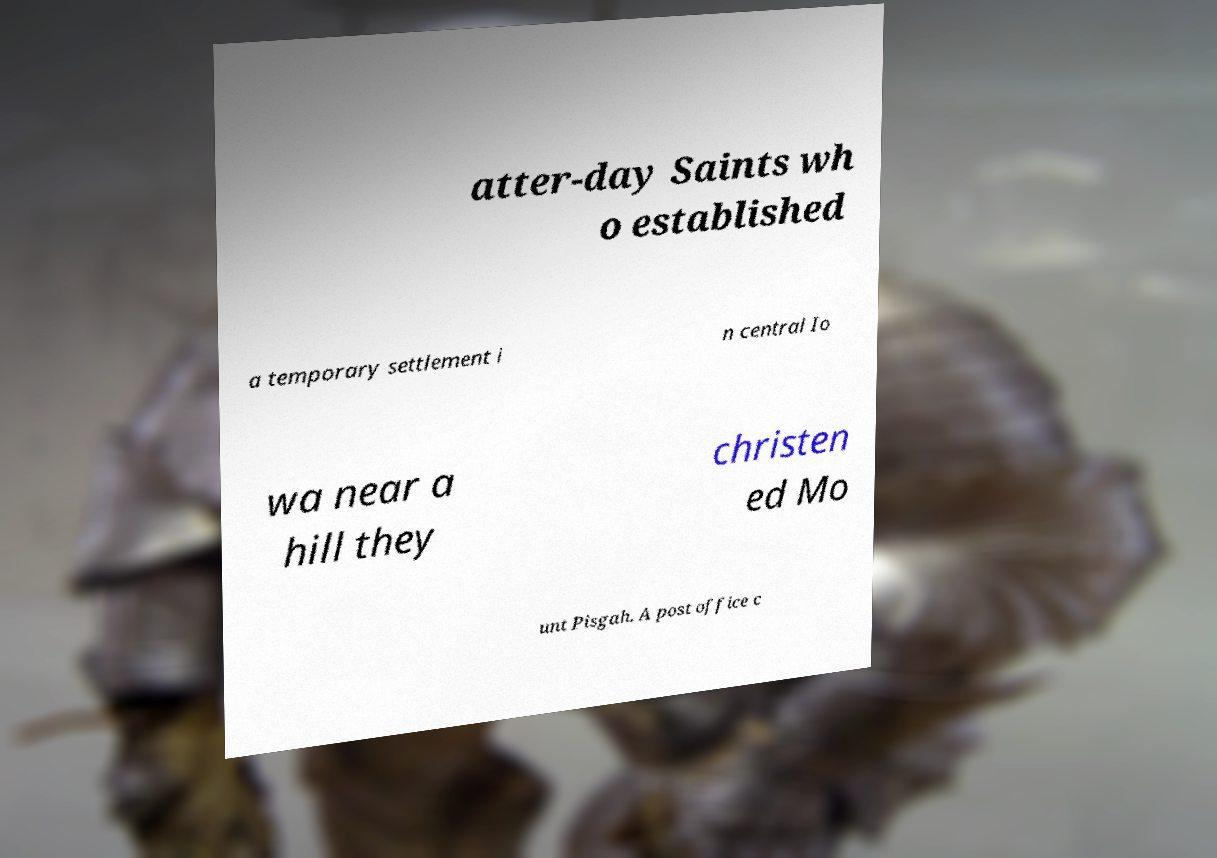Can you accurately transcribe the text from the provided image for me? atter-day Saints wh o established a temporary settlement i n central Io wa near a hill they christen ed Mo unt Pisgah. A post office c 